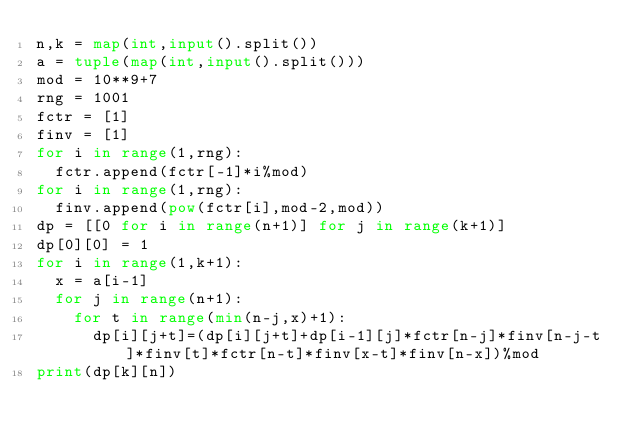Convert code to text. <code><loc_0><loc_0><loc_500><loc_500><_Python_>n,k = map(int,input().split())
a = tuple(map(int,input().split()))
mod = 10**9+7
rng = 1001
fctr = [1]
finv = [1]
for i in range(1,rng):
  fctr.append(fctr[-1]*i%mod)
for i in range(1,rng):
  finv.append(pow(fctr[i],mod-2,mod))
dp = [[0 for i in range(n+1)] for j in range(k+1)]
dp[0][0] = 1
for i in range(1,k+1):
  x = a[i-1]
  for j in range(n+1):
    for t in range(min(n-j,x)+1):
      dp[i][j+t]=(dp[i][j+t]+dp[i-1][j]*fctr[n-j]*finv[n-j-t]*finv[t]*fctr[n-t]*finv[x-t]*finv[n-x])%mod
print(dp[k][n])</code> 